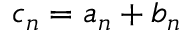Convert formula to latex. <formula><loc_0><loc_0><loc_500><loc_500>c _ { n } = a _ { n } + b _ { n }</formula> 